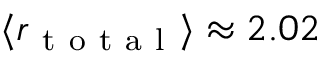<formula> <loc_0><loc_0><loc_500><loc_500>\langle r _ { t o t a l } \rangle \approx 2 . 0 2</formula> 